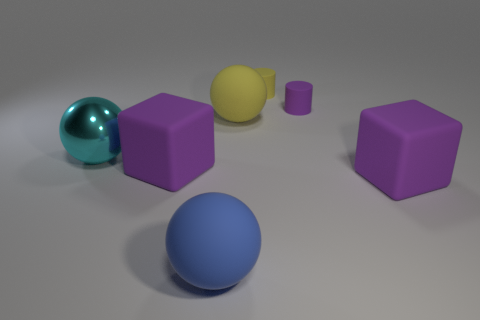There is a yellow cylinder that is the same size as the purple matte cylinder; what is it made of? While the image doesn't specifically indicate the material of the objects, based on the common characteristics of objects that are visually similar, the yellow cylinder could conceivably be made of a plastic material, identifiable by its uniform color and smooth surface. 